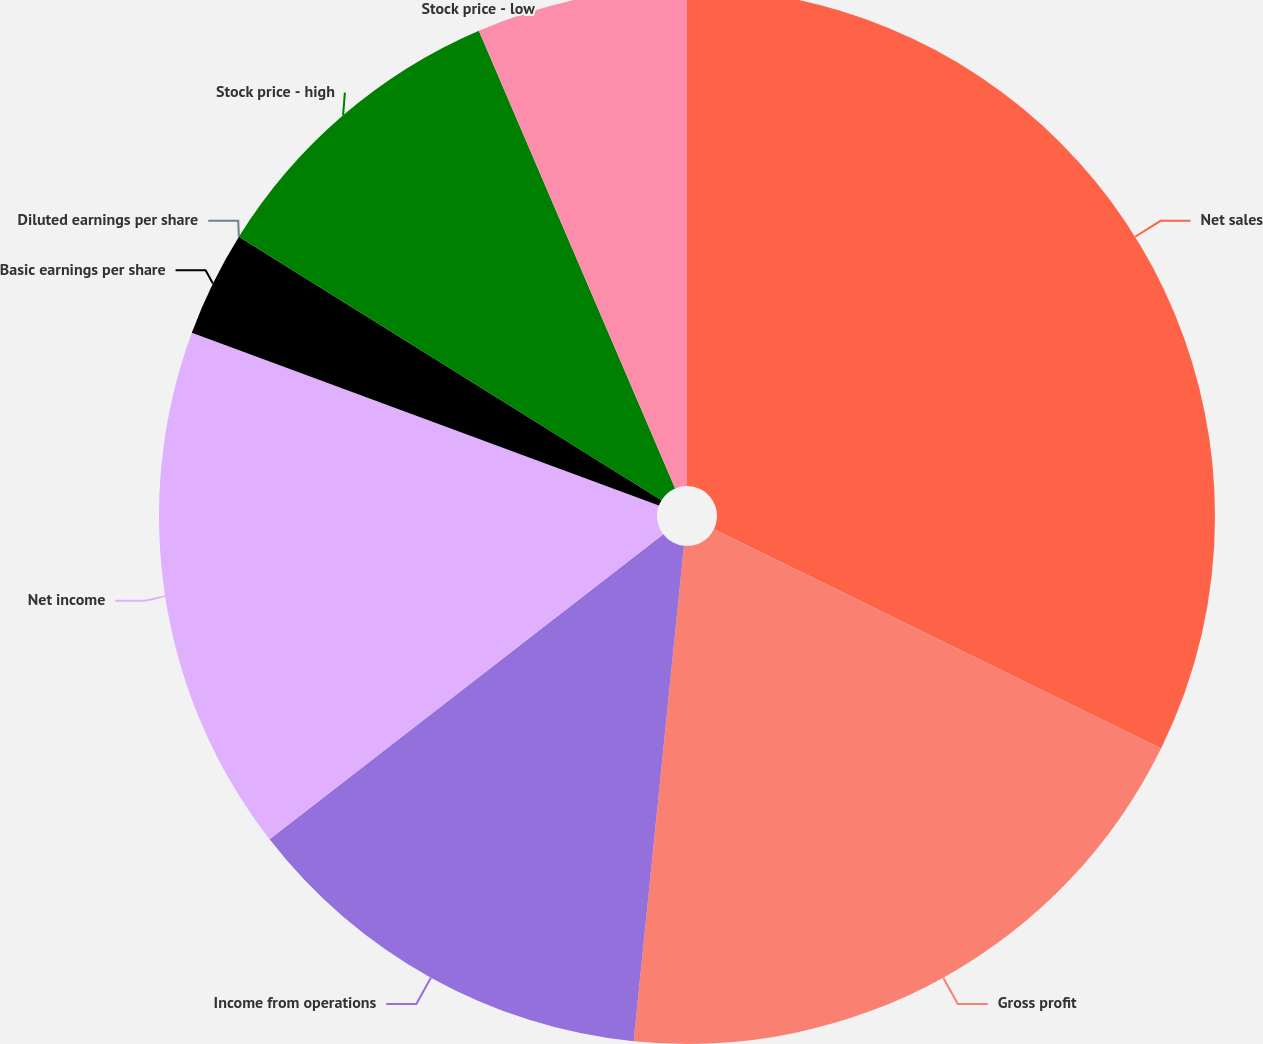<chart> <loc_0><loc_0><loc_500><loc_500><pie_chart><fcel>Net sales<fcel>Gross profit<fcel>Income from operations<fcel>Net income<fcel>Basic earnings per share<fcel>Diluted earnings per share<fcel>Stock price - high<fcel>Stock price - low<nl><fcel>32.26%<fcel>19.35%<fcel>12.9%<fcel>16.13%<fcel>3.23%<fcel>0.0%<fcel>9.68%<fcel>6.45%<nl></chart> 